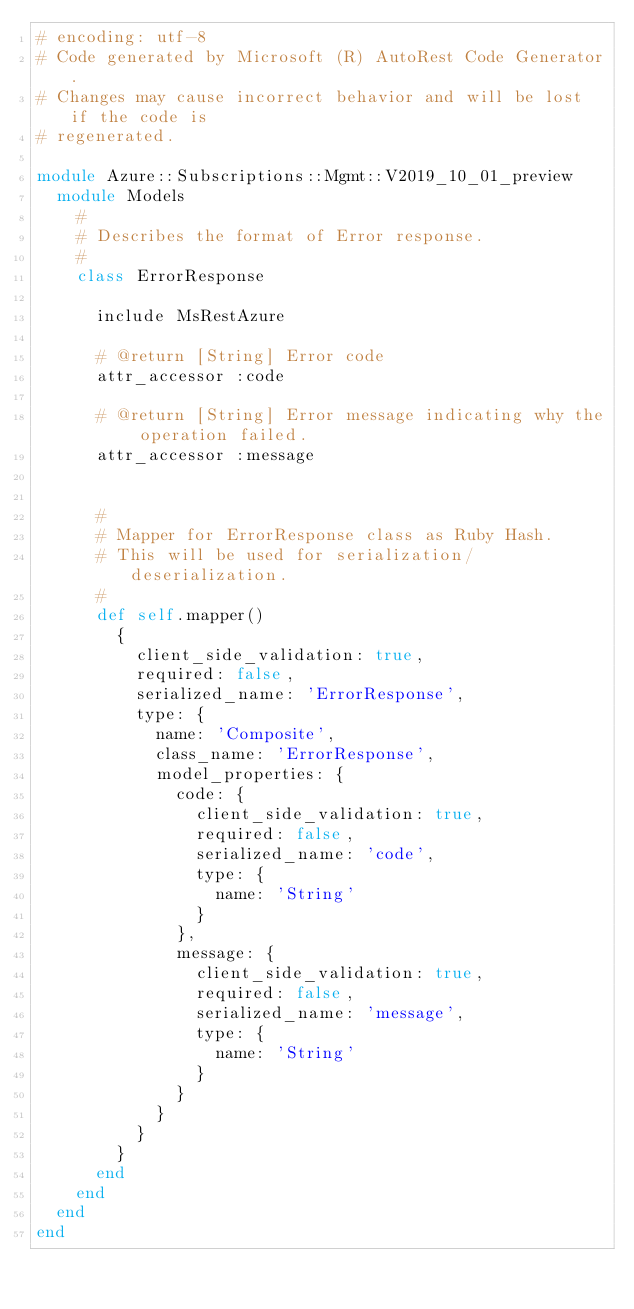Convert code to text. <code><loc_0><loc_0><loc_500><loc_500><_Ruby_># encoding: utf-8
# Code generated by Microsoft (R) AutoRest Code Generator.
# Changes may cause incorrect behavior and will be lost if the code is
# regenerated.

module Azure::Subscriptions::Mgmt::V2019_10_01_preview
  module Models
    #
    # Describes the format of Error response.
    #
    class ErrorResponse

      include MsRestAzure

      # @return [String] Error code
      attr_accessor :code

      # @return [String] Error message indicating why the operation failed.
      attr_accessor :message


      #
      # Mapper for ErrorResponse class as Ruby Hash.
      # This will be used for serialization/deserialization.
      #
      def self.mapper()
        {
          client_side_validation: true,
          required: false,
          serialized_name: 'ErrorResponse',
          type: {
            name: 'Composite',
            class_name: 'ErrorResponse',
            model_properties: {
              code: {
                client_side_validation: true,
                required: false,
                serialized_name: 'code',
                type: {
                  name: 'String'
                }
              },
              message: {
                client_side_validation: true,
                required: false,
                serialized_name: 'message',
                type: {
                  name: 'String'
                }
              }
            }
          }
        }
      end
    end
  end
end
</code> 